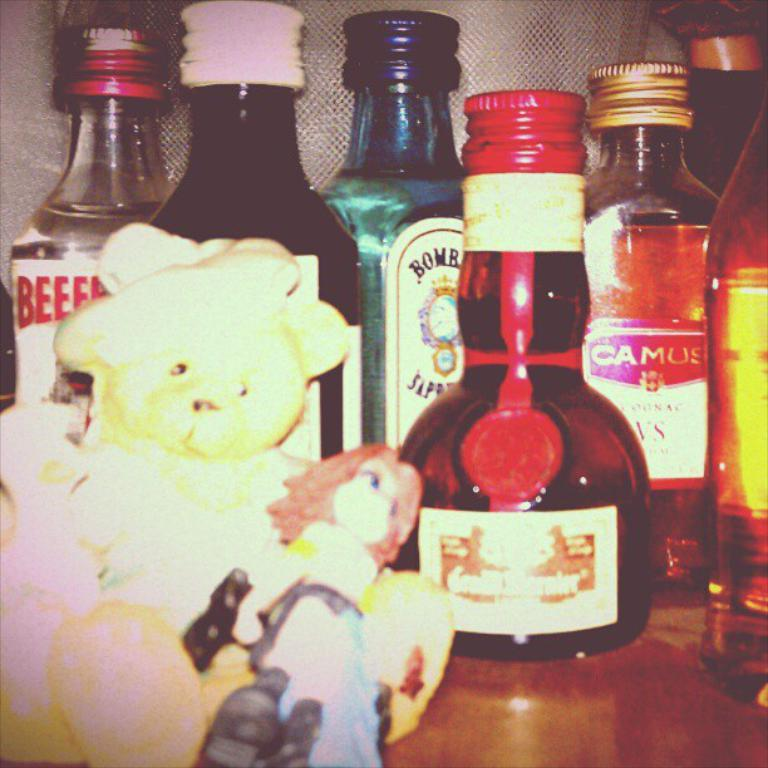How many glass bottles are visible in the image? There are six glass bottles in the image. What type of cap do the bottles have? The bottles have metal caps. What is the size of the bottles in the image? The bottles are described as a small toy. Where are the bottles located in the image? The bottles are placed on a table. How can the contents of each bottle be identified? Each bottle has a label attached to it. What type of skin condition can be seen on the bottles in the image? There is no skin condition present on the bottles in the image, as they are glass bottles with metal caps and labels. 